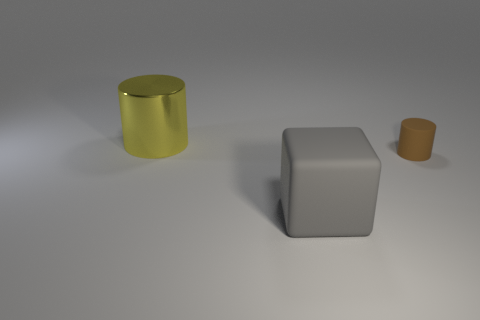Add 3 big gray matte objects. How many objects exist? 6 Subtract all gray matte objects. Subtract all small cylinders. How many objects are left? 1 Add 1 gray matte objects. How many gray matte objects are left? 2 Add 3 large yellow cylinders. How many large yellow cylinders exist? 4 Subtract 0 red cylinders. How many objects are left? 3 Subtract all blocks. How many objects are left? 2 